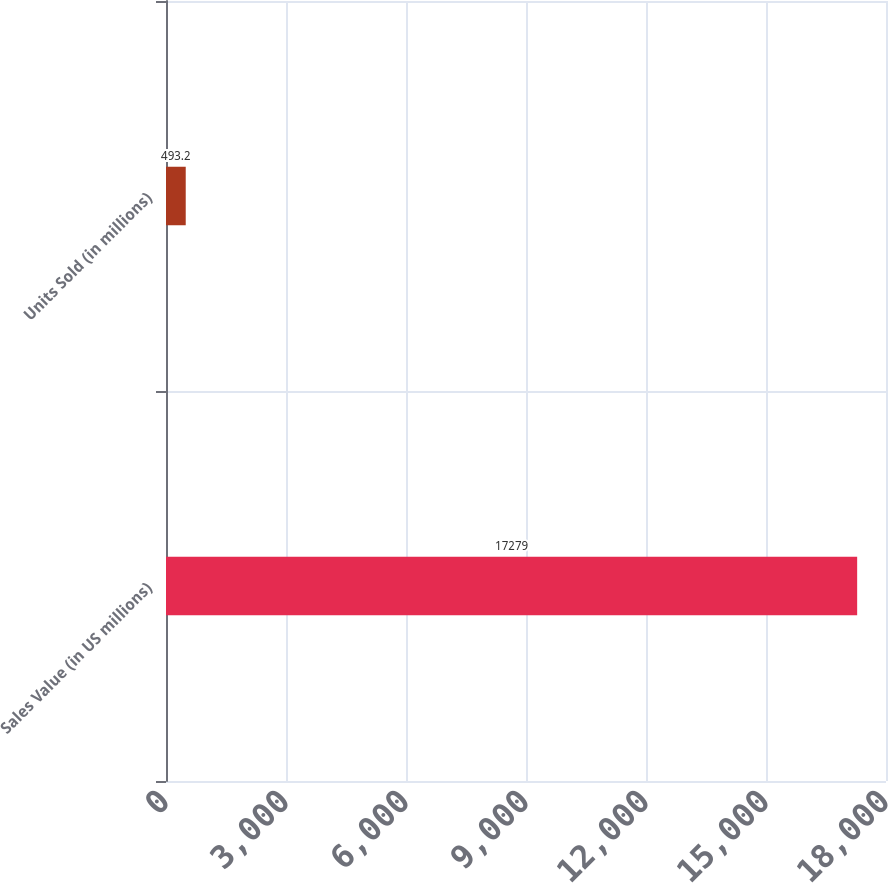Convert chart. <chart><loc_0><loc_0><loc_500><loc_500><bar_chart><fcel>Sales Value (in US millions)<fcel>Units Sold (in millions)<nl><fcel>17279<fcel>493.2<nl></chart> 